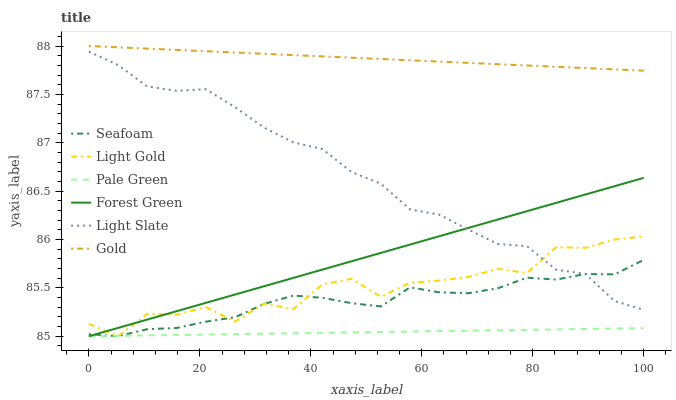Does Pale Green have the minimum area under the curve?
Answer yes or no. Yes. Does Gold have the maximum area under the curve?
Answer yes or no. Yes. Does Light Slate have the minimum area under the curve?
Answer yes or no. No. Does Light Slate have the maximum area under the curve?
Answer yes or no. No. Is Forest Green the smoothest?
Answer yes or no. Yes. Is Light Gold the roughest?
Answer yes or no. Yes. Is Light Slate the smoothest?
Answer yes or no. No. Is Light Slate the roughest?
Answer yes or no. No. Does Seafoam have the lowest value?
Answer yes or no. Yes. Does Light Slate have the lowest value?
Answer yes or no. No. Does Gold have the highest value?
Answer yes or no. Yes. Does Light Slate have the highest value?
Answer yes or no. No. Is Pale Green less than Light Slate?
Answer yes or no. Yes. Is Gold greater than Pale Green?
Answer yes or no. Yes. Does Light Gold intersect Light Slate?
Answer yes or no. Yes. Is Light Gold less than Light Slate?
Answer yes or no. No. Is Light Gold greater than Light Slate?
Answer yes or no. No. Does Pale Green intersect Light Slate?
Answer yes or no. No. 